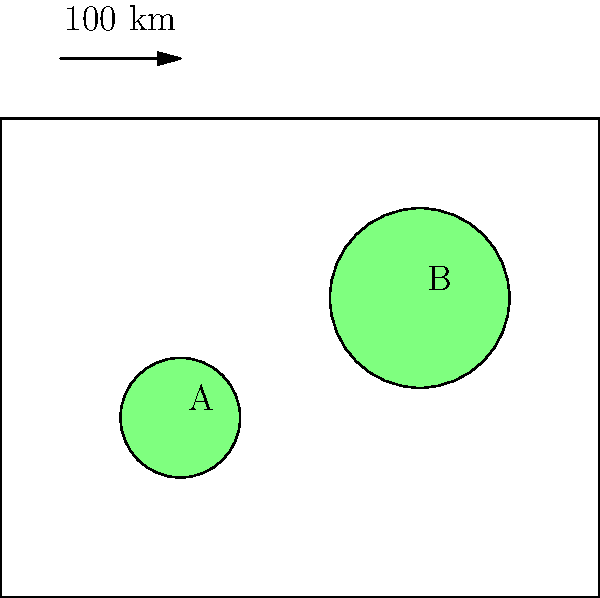A simplified map of China's natural gas reserves is shown above. Reserve A has a diameter of 20 km, while reserve B has a diameter of 30 km. If the map scale is 1:1,000,000, and gas output is proportional to the area of the reserve, how many times more gas does reserve B produce compared to reserve A? To solve this problem, we need to follow these steps:

1) First, let's calculate the actual diameters of the reserves:
   Scale is 1:1,000,000, so 1 cm on the map = 10 km in reality
   Reserve A: 20 km actual diameter
   Reserve B: 30 km actual diameter

2) Now, let's calculate the areas of both reserves using the formula $A = \pi r^2$:
   Reserve A: $A_A = \pi (10)^2 = 100\pi$ km²
   Reserve B: $A_B = \pi (15)^2 = 225\pi$ km²

3) To find how many times more gas B produces, we divide the area of B by the area of A:
   $\frac{A_B}{A_A} = \frac{225\pi}{100\pi} = 2.25$

Therefore, reserve B produces 2.25 times more gas than reserve A.
Answer: 2.25 times 